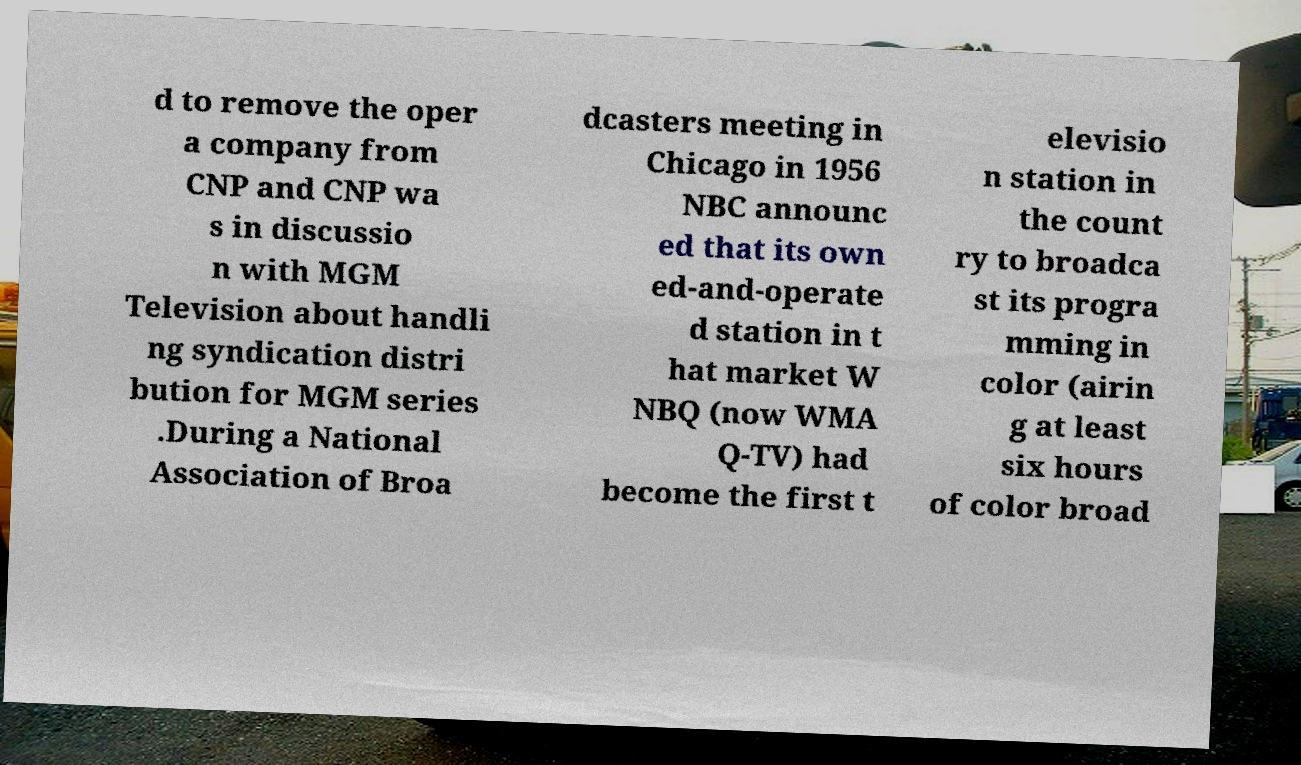Can you accurately transcribe the text from the provided image for me? d to remove the oper a company from CNP and CNP wa s in discussio n with MGM Television about handli ng syndication distri bution for MGM series .During a National Association of Broa dcasters meeting in Chicago in 1956 NBC announc ed that its own ed-and-operate d station in t hat market W NBQ (now WMA Q-TV) had become the first t elevisio n station in the count ry to broadca st its progra mming in color (airin g at least six hours of color broad 